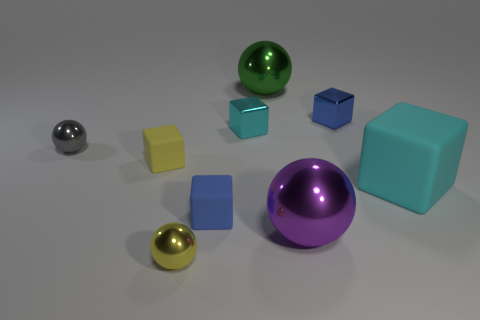What is the color of the other shiny ball that is the same size as the yellow metal ball?
Your response must be concise. Gray. How many purple things are either matte balls or large metallic objects?
Your answer should be very brief. 1. Is the number of tiny cyan cubes greater than the number of big gray metallic cubes?
Ensure brevity in your answer.  Yes. There is a green sphere that is behind the large purple ball; is its size the same as the cyan cube that is on the right side of the purple metallic sphere?
Provide a short and direct response. Yes. What color is the small rubber block that is right of the small rubber cube that is to the left of the tiny metallic object that is in front of the purple ball?
Ensure brevity in your answer.  Blue. Are there any small metal objects that have the same shape as the large green object?
Provide a short and direct response. Yes. Is the number of big matte blocks behind the yellow matte cube greater than the number of tiny blue blocks?
Offer a terse response. No. What number of matte objects are either big cylinders or cubes?
Ensure brevity in your answer.  3. What is the size of the block that is to the left of the large purple metal thing and in front of the tiny yellow matte cube?
Your response must be concise. Small. Is there a shiny cube that is in front of the large shiny sphere that is in front of the green thing?
Ensure brevity in your answer.  No. 